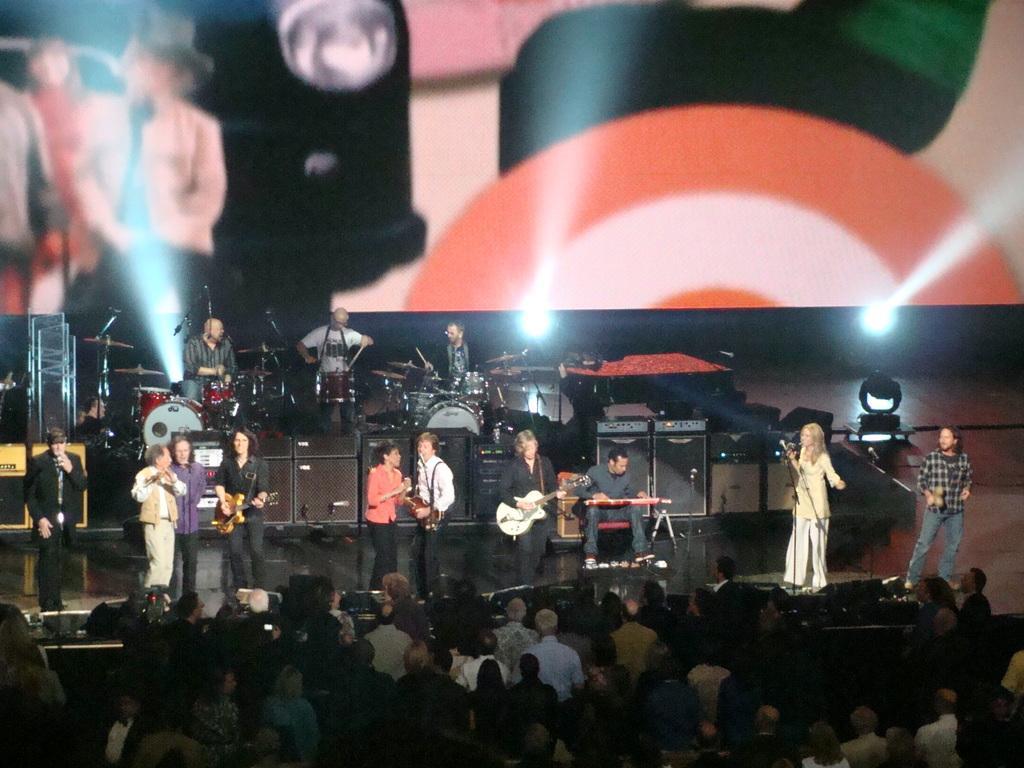Please provide a concise description of this image. The picture is from a live concert. In the center of the picture there is a stage, on the stage there are lot of people performing. In the foreground there is a crowd standing. In the background there is a screen. 